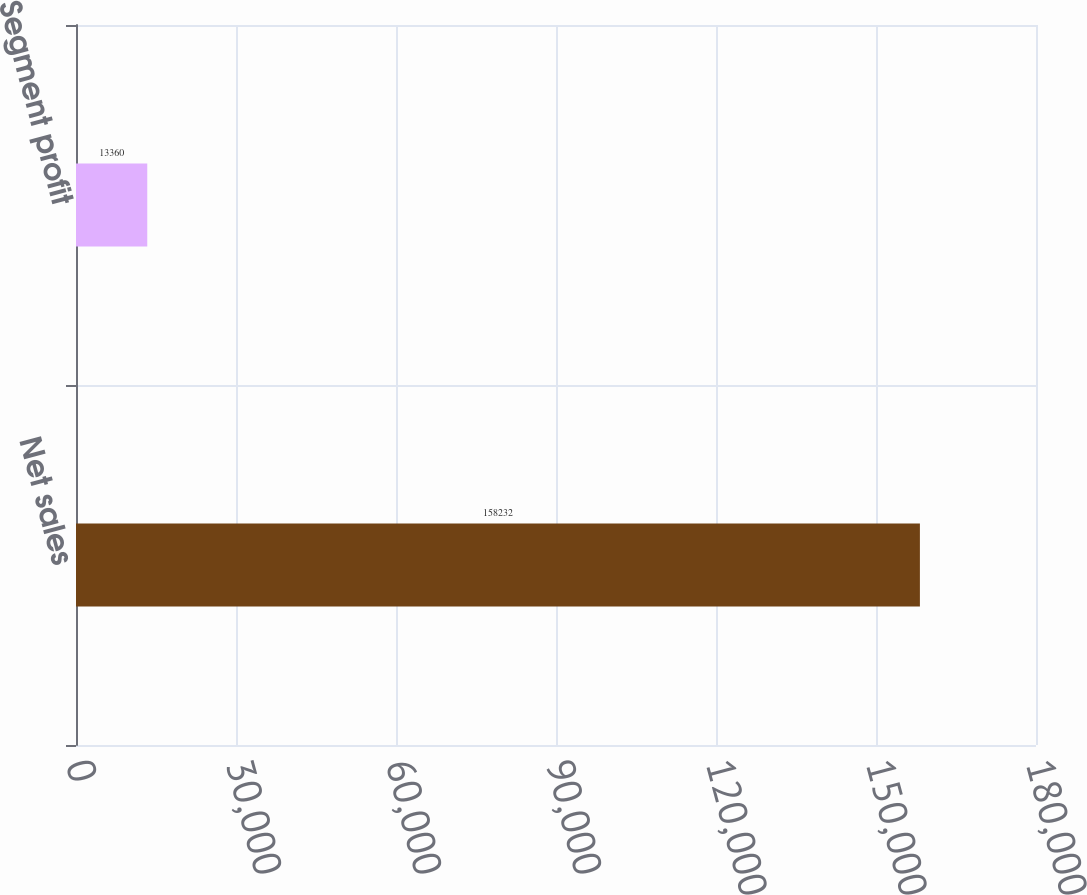Convert chart. <chart><loc_0><loc_0><loc_500><loc_500><bar_chart><fcel>Net sales<fcel>Segment profit<nl><fcel>158232<fcel>13360<nl></chart> 